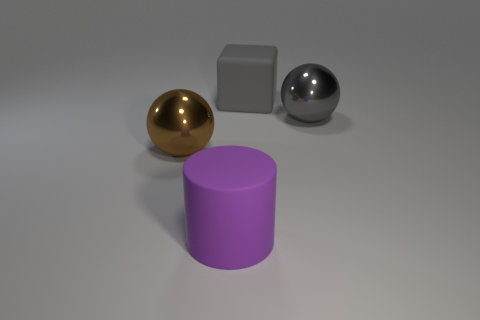How many things are gray things on the right side of the cylinder or big balls to the right of the purple matte object?
Your answer should be very brief. 2. Does the big sphere to the left of the large cube have the same material as the big ball on the right side of the big gray rubber thing?
Offer a very short reply. Yes. Is the number of large cylinders that are behind the big purple matte cylinder the same as the number of metal objects behind the brown sphere?
Your response must be concise. No. What number of metal balls have the same color as the block?
Offer a very short reply. 1. What material is the object that is the same color as the matte cube?
Make the answer very short. Metal. What number of rubber things are either cubes or purple things?
Provide a succinct answer. 2. There is a big metal thing that is behind the brown object; does it have the same shape as the metallic object on the left side of the big rubber block?
Ensure brevity in your answer.  Yes. How many large brown metallic spheres are in front of the large block?
Give a very brief answer. 1. Are there any big gray objects made of the same material as the cylinder?
Make the answer very short. Yes. There is another gray thing that is the same size as the gray metal object; what is it made of?
Give a very brief answer. Rubber. 